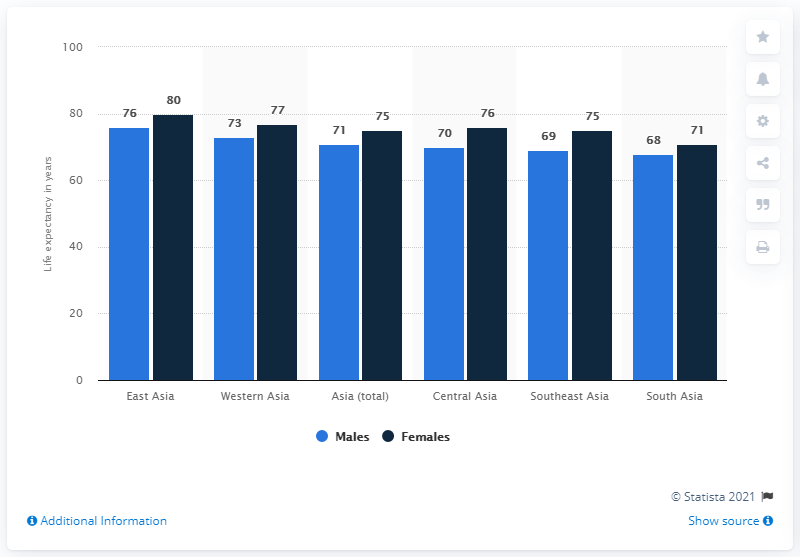What's the difference between the leftmost and rightmost bars values in this graph? The difference between the leftmost bar, representing life expectancy in Western Asia (80 years), and the rightmost bar, representing life expectancy in South Asia (75 years), is 5 years. This indicates a regional variation in life expectancy within Asia, with Western Asia having a slightly higher expectancy than South Asia. 